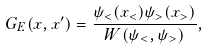<formula> <loc_0><loc_0><loc_500><loc_500>G _ { E } ( x , x ^ { \prime } ) = \frac { \psi _ { < } ( x _ { < } ) \psi _ { > } ( x _ { > } ) } { W ( \psi _ { < } , \psi _ { > } ) } ,</formula> 